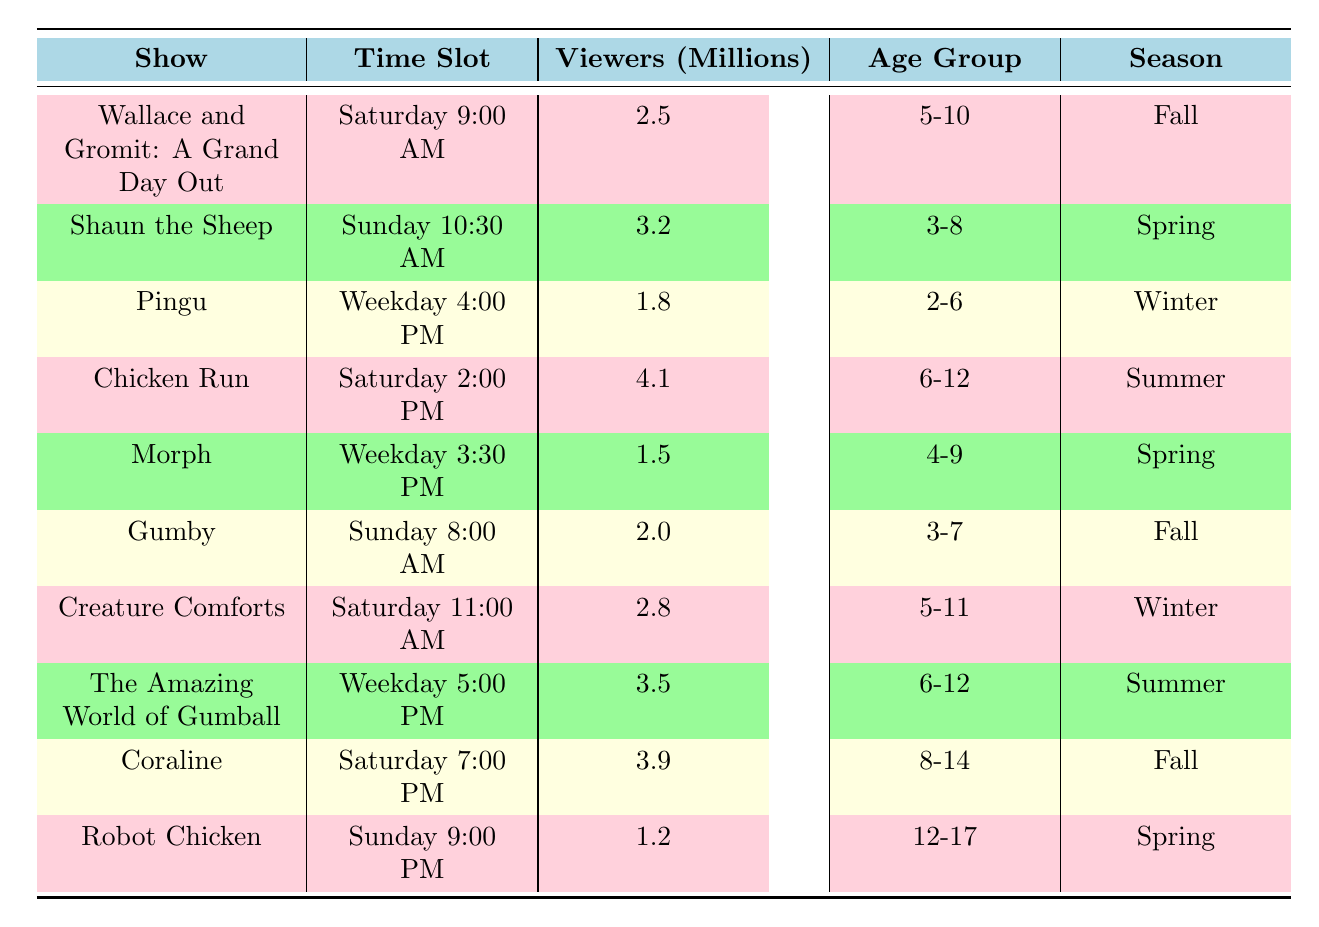What are the viewership numbers for "Chicken Run"? The table shows that "Chicken Run," which airs on Saturday at 2:00 PM, has a viewership of 4.1 million.
Answer: 4.1 million Which claymation show has the highest number of viewers? By comparing the viewership numbers in the table, "Chicken Run" has the highest viewers at 4.1 million.
Answer: "Chicken Run" Is "Gumby" shown on a weekday? The table indicates "Gumby" is aired on Sunday at 8:00 AM, which is not a weekday.
Answer: No What is the total viewership for shows aired on Saturday? Adding the viewership for Saturday shows: Wallace and Gromit (2.5) + Chicken Run (4.1) + Creature Comforts (2.8) + Coraline (3.9) gives a total: 2.5 + 4.1 + 2.8 + 3.9 = 13.3 million viewers.
Answer: 13.3 million How many shows are targeted at the age group 6-12? Looking at the table, "Chicken Run," "The Amazing World of Gumball," and "Creature Comforts" are aimed at the 6-12 age group, meaning there are 3 shows.
Answer: 3 shows Which show has more viewers, "Wallace and Gromit: A Grand Day Out" or "Morph"? The table shows "Wallace and Gromit" has 2.5 million viewers and "Morph" has 1.5 million viewers. Since 2.5 is greater than 1.5, "Wallace and Gromit" has more viewers.
Answer: "Wallace and Gromit: A Grand Day Out" What is the average viewership for shows aired on Sundays? The two shows on Sunday are "Shaun the Sheep" with 3.2 million viewers and "Gumby" with 2.0 million views. To find the average, add them together: 3.2 + 2.0 = 5.2 million, then divide by 2: 5.2 / 2 = 2.6 million.
Answer: 2.6 million Is there any show with less than 2 million viewers? "Pingu" has 1.8 million viewers, which is less than 2 million, so this is true.
Answer: Yes How many total viewers does "Robot Chicken" have compared to "Coraline"? "Robot Chicken" has 1.2 million viewers, and "Coraline" has 3.9 million viewers. The difference is calculated by subtracting 1.2 from 3.9: 3.9 - 1.2 = 2.7 million more viewers for "Coraline."
Answer: 2.7 million more viewers for "Coraline" 